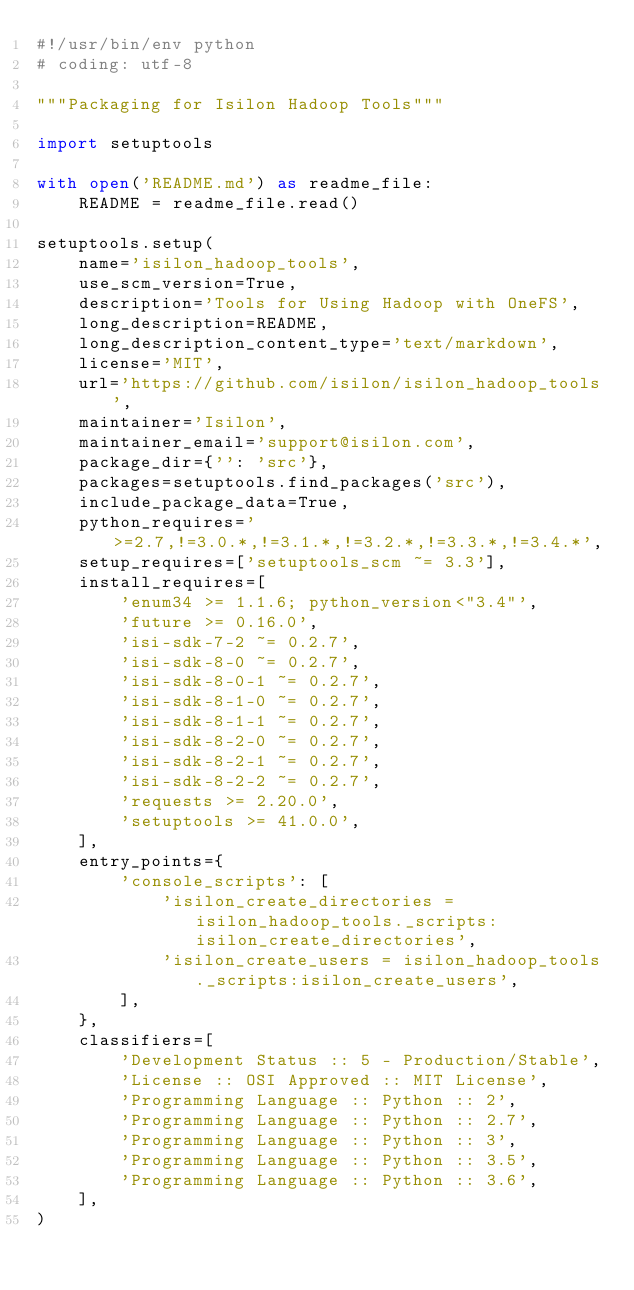<code> <loc_0><loc_0><loc_500><loc_500><_Python_>#!/usr/bin/env python
# coding: utf-8

"""Packaging for Isilon Hadoop Tools"""

import setuptools

with open('README.md') as readme_file:
    README = readme_file.read()

setuptools.setup(
    name='isilon_hadoop_tools',
    use_scm_version=True,
    description='Tools for Using Hadoop with OneFS',
    long_description=README,
    long_description_content_type='text/markdown',
    license='MIT',
    url='https://github.com/isilon/isilon_hadoop_tools',
    maintainer='Isilon',
    maintainer_email='support@isilon.com',
    package_dir={'': 'src'},
    packages=setuptools.find_packages('src'),
    include_package_data=True,
    python_requires='>=2.7,!=3.0.*,!=3.1.*,!=3.2.*,!=3.3.*,!=3.4.*',
    setup_requires=['setuptools_scm ~= 3.3'],
    install_requires=[
        'enum34 >= 1.1.6; python_version<"3.4"',
        'future >= 0.16.0',
        'isi-sdk-7-2 ~= 0.2.7',
        'isi-sdk-8-0 ~= 0.2.7',
        'isi-sdk-8-0-1 ~= 0.2.7',
        'isi-sdk-8-1-0 ~= 0.2.7',
        'isi-sdk-8-1-1 ~= 0.2.7',
        'isi-sdk-8-2-0 ~= 0.2.7',
        'isi-sdk-8-2-1 ~= 0.2.7',
        'isi-sdk-8-2-2 ~= 0.2.7',
        'requests >= 2.20.0',
        'setuptools >= 41.0.0',
    ],
    entry_points={
        'console_scripts': [
            'isilon_create_directories = isilon_hadoop_tools._scripts:isilon_create_directories',
            'isilon_create_users = isilon_hadoop_tools._scripts:isilon_create_users',
        ],
    },
    classifiers=[
        'Development Status :: 5 - Production/Stable',
        'License :: OSI Approved :: MIT License',
        'Programming Language :: Python :: 2',
        'Programming Language :: Python :: 2.7',
        'Programming Language :: Python :: 3',
        'Programming Language :: Python :: 3.5',
        'Programming Language :: Python :: 3.6',
    ],
)
</code> 